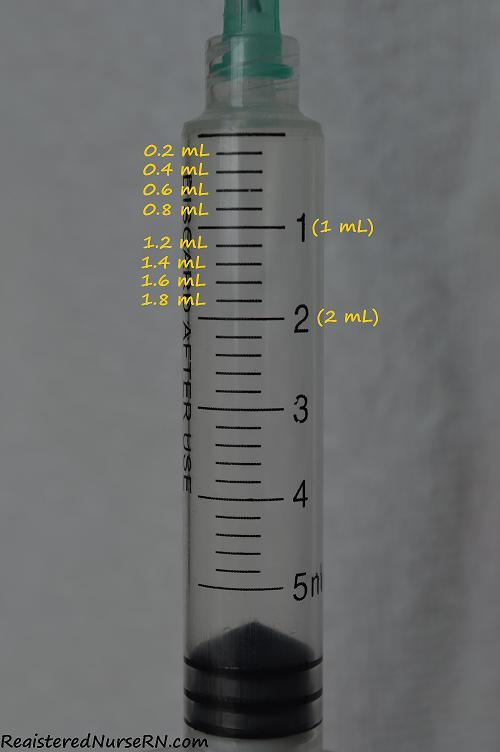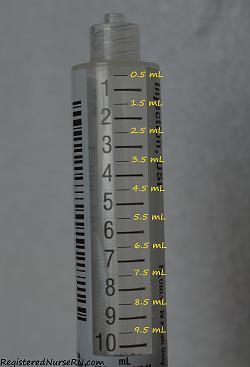The first image is the image on the left, the second image is the image on the right. Evaluate the accuracy of this statement regarding the images: "One of the syringes has a green tip.". Is it true? Answer yes or no. Yes. The first image is the image on the left, the second image is the image on the right. For the images shown, is this caption "At least one photo contains a syringe with a green tip." true? Answer yes or no. Yes. 